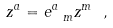<formula> <loc_0><loc_0><loc_500><loc_500>z ^ { a } = e _ { \ m } ^ { a } z ^ { m } \ ,</formula> 